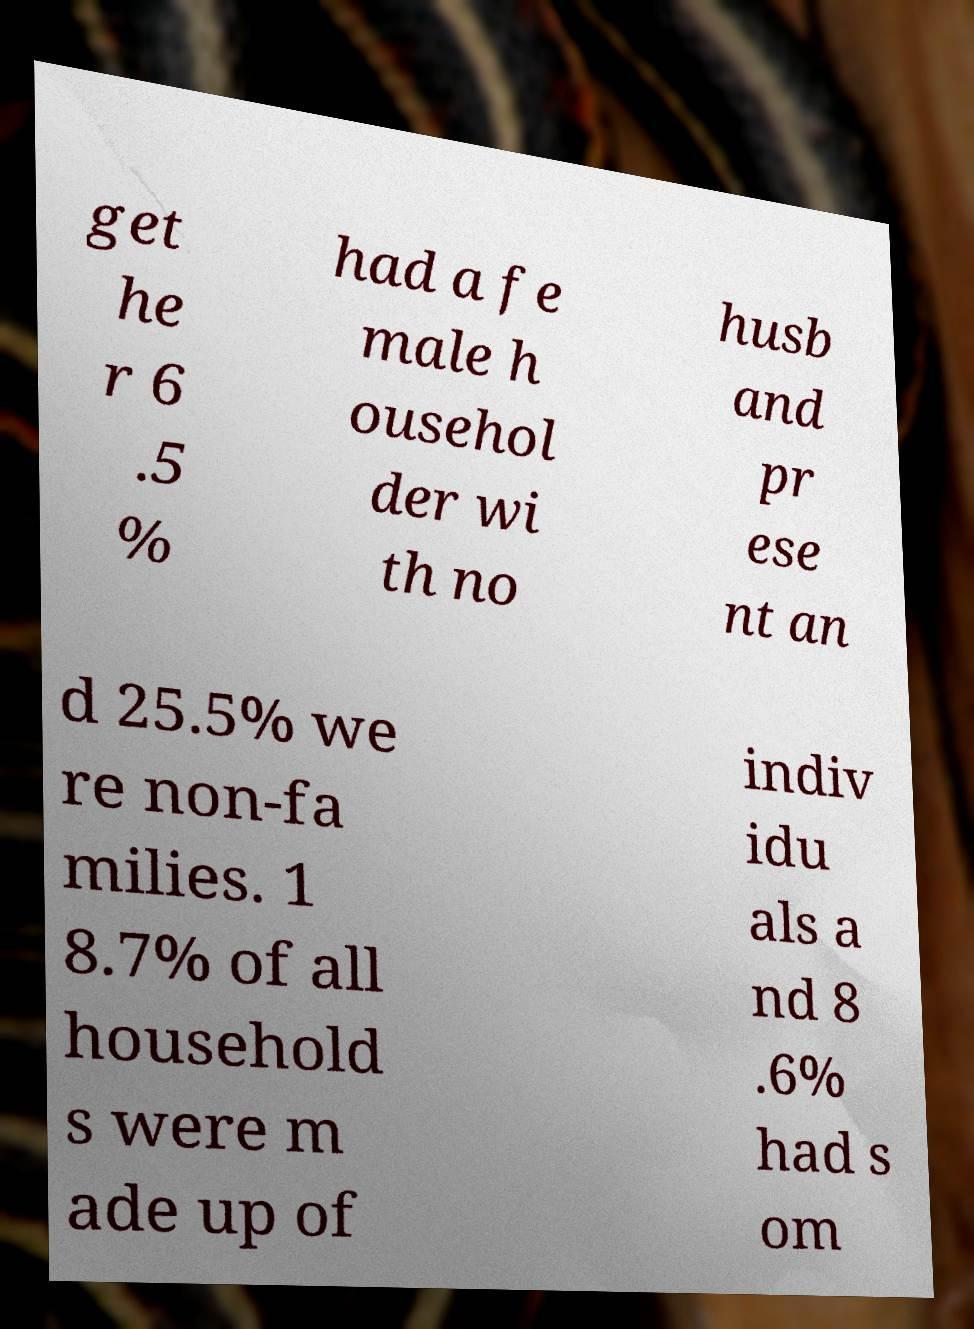Could you assist in decoding the text presented in this image and type it out clearly? get he r 6 .5 % had a fe male h ousehol der wi th no husb and pr ese nt an d 25.5% we re non-fa milies. 1 8.7% of all household s were m ade up of indiv idu als a nd 8 .6% had s om 